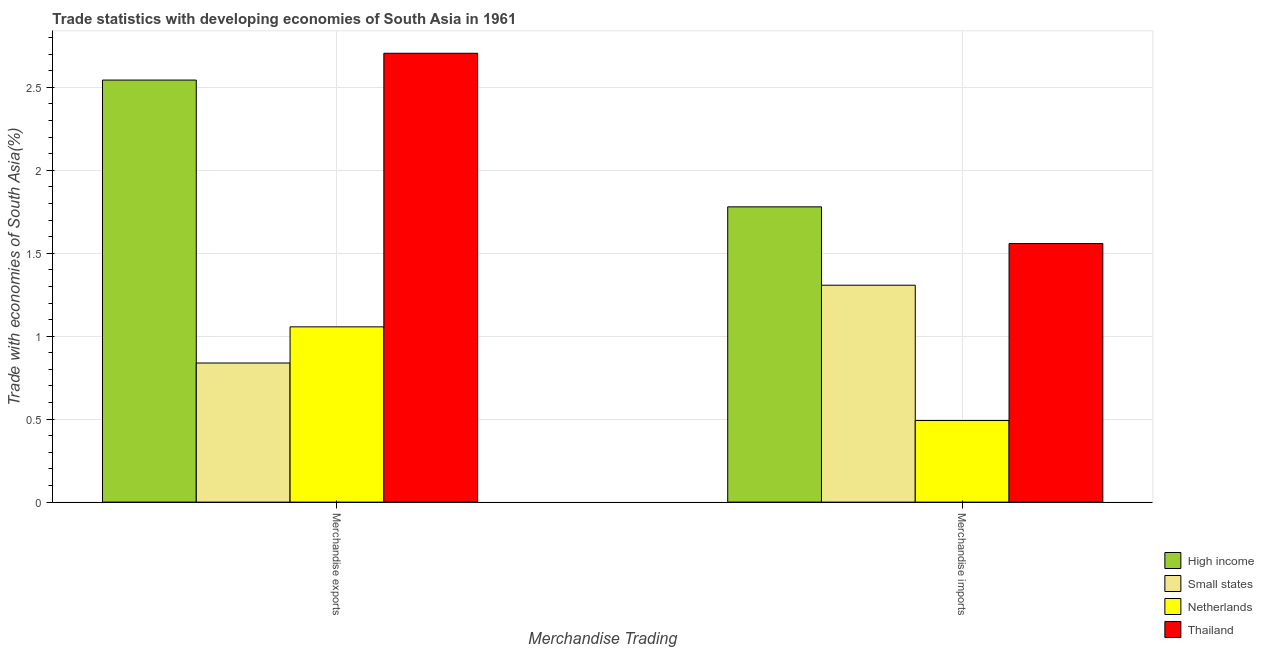How many different coloured bars are there?
Ensure brevity in your answer.  4. How many groups of bars are there?
Your response must be concise. 2. Are the number of bars per tick equal to the number of legend labels?
Give a very brief answer. Yes. How many bars are there on the 1st tick from the left?
Provide a short and direct response. 4. How many bars are there on the 2nd tick from the right?
Ensure brevity in your answer.  4. What is the merchandise imports in High income?
Provide a short and direct response. 1.78. Across all countries, what is the maximum merchandise exports?
Make the answer very short. 2.71. Across all countries, what is the minimum merchandise imports?
Your response must be concise. 0.49. In which country was the merchandise imports maximum?
Provide a short and direct response. High income. In which country was the merchandise imports minimum?
Make the answer very short. Netherlands. What is the total merchandise exports in the graph?
Ensure brevity in your answer.  7.14. What is the difference between the merchandise imports in Small states and that in High income?
Your response must be concise. -0.47. What is the difference between the merchandise exports in Netherlands and the merchandise imports in Small states?
Make the answer very short. -0.25. What is the average merchandise exports per country?
Ensure brevity in your answer.  1.79. What is the difference between the merchandise exports and merchandise imports in Thailand?
Provide a short and direct response. 1.15. What is the ratio of the merchandise exports in High income to that in Small states?
Provide a short and direct response. 3.03. Is the merchandise exports in Small states less than that in Thailand?
Offer a terse response. Yes. What does the 3rd bar from the left in Merchandise exports represents?
Make the answer very short. Netherlands. What does the 3rd bar from the right in Merchandise imports represents?
Provide a short and direct response. Small states. How many bars are there?
Keep it short and to the point. 8. Are all the bars in the graph horizontal?
Keep it short and to the point. No. How many countries are there in the graph?
Provide a short and direct response. 4. What is the difference between two consecutive major ticks on the Y-axis?
Your response must be concise. 0.5. Does the graph contain any zero values?
Your answer should be very brief. No. Where does the legend appear in the graph?
Ensure brevity in your answer.  Bottom right. How many legend labels are there?
Ensure brevity in your answer.  4. How are the legend labels stacked?
Provide a succinct answer. Vertical. What is the title of the graph?
Your response must be concise. Trade statistics with developing economies of South Asia in 1961. What is the label or title of the X-axis?
Offer a very short reply. Merchandise Trading. What is the label or title of the Y-axis?
Keep it short and to the point. Trade with economies of South Asia(%). What is the Trade with economies of South Asia(%) in High income in Merchandise exports?
Your answer should be compact. 2.54. What is the Trade with economies of South Asia(%) in Small states in Merchandise exports?
Ensure brevity in your answer.  0.84. What is the Trade with economies of South Asia(%) of Netherlands in Merchandise exports?
Offer a terse response. 1.06. What is the Trade with economies of South Asia(%) in Thailand in Merchandise exports?
Offer a very short reply. 2.71. What is the Trade with economies of South Asia(%) in High income in Merchandise imports?
Your answer should be compact. 1.78. What is the Trade with economies of South Asia(%) of Small states in Merchandise imports?
Your answer should be compact. 1.31. What is the Trade with economies of South Asia(%) in Netherlands in Merchandise imports?
Give a very brief answer. 0.49. What is the Trade with economies of South Asia(%) in Thailand in Merchandise imports?
Give a very brief answer. 1.56. Across all Merchandise Trading, what is the maximum Trade with economies of South Asia(%) of High income?
Keep it short and to the point. 2.54. Across all Merchandise Trading, what is the maximum Trade with economies of South Asia(%) of Small states?
Your answer should be very brief. 1.31. Across all Merchandise Trading, what is the maximum Trade with economies of South Asia(%) in Netherlands?
Provide a short and direct response. 1.06. Across all Merchandise Trading, what is the maximum Trade with economies of South Asia(%) of Thailand?
Provide a succinct answer. 2.71. Across all Merchandise Trading, what is the minimum Trade with economies of South Asia(%) of High income?
Provide a succinct answer. 1.78. Across all Merchandise Trading, what is the minimum Trade with economies of South Asia(%) in Small states?
Your answer should be very brief. 0.84. Across all Merchandise Trading, what is the minimum Trade with economies of South Asia(%) of Netherlands?
Offer a terse response. 0.49. Across all Merchandise Trading, what is the minimum Trade with economies of South Asia(%) in Thailand?
Make the answer very short. 1.56. What is the total Trade with economies of South Asia(%) in High income in the graph?
Provide a short and direct response. 4.32. What is the total Trade with economies of South Asia(%) in Small states in the graph?
Your answer should be compact. 2.15. What is the total Trade with economies of South Asia(%) of Netherlands in the graph?
Provide a succinct answer. 1.55. What is the total Trade with economies of South Asia(%) in Thailand in the graph?
Ensure brevity in your answer.  4.26. What is the difference between the Trade with economies of South Asia(%) in High income in Merchandise exports and that in Merchandise imports?
Your answer should be compact. 0.76. What is the difference between the Trade with economies of South Asia(%) of Small states in Merchandise exports and that in Merchandise imports?
Give a very brief answer. -0.47. What is the difference between the Trade with economies of South Asia(%) in Netherlands in Merchandise exports and that in Merchandise imports?
Provide a succinct answer. 0.56. What is the difference between the Trade with economies of South Asia(%) in Thailand in Merchandise exports and that in Merchandise imports?
Offer a terse response. 1.15. What is the difference between the Trade with economies of South Asia(%) in High income in Merchandise exports and the Trade with economies of South Asia(%) in Small states in Merchandise imports?
Provide a succinct answer. 1.24. What is the difference between the Trade with economies of South Asia(%) in High income in Merchandise exports and the Trade with economies of South Asia(%) in Netherlands in Merchandise imports?
Provide a short and direct response. 2.05. What is the difference between the Trade with economies of South Asia(%) of High income in Merchandise exports and the Trade with economies of South Asia(%) of Thailand in Merchandise imports?
Provide a short and direct response. 0.99. What is the difference between the Trade with economies of South Asia(%) in Small states in Merchandise exports and the Trade with economies of South Asia(%) in Netherlands in Merchandise imports?
Offer a terse response. 0.35. What is the difference between the Trade with economies of South Asia(%) of Small states in Merchandise exports and the Trade with economies of South Asia(%) of Thailand in Merchandise imports?
Your response must be concise. -0.72. What is the difference between the Trade with economies of South Asia(%) in Netherlands in Merchandise exports and the Trade with economies of South Asia(%) in Thailand in Merchandise imports?
Give a very brief answer. -0.5. What is the average Trade with economies of South Asia(%) of High income per Merchandise Trading?
Provide a short and direct response. 2.16. What is the average Trade with economies of South Asia(%) in Small states per Merchandise Trading?
Offer a very short reply. 1.07. What is the average Trade with economies of South Asia(%) of Netherlands per Merchandise Trading?
Offer a very short reply. 0.77. What is the average Trade with economies of South Asia(%) in Thailand per Merchandise Trading?
Offer a terse response. 2.13. What is the difference between the Trade with economies of South Asia(%) in High income and Trade with economies of South Asia(%) in Small states in Merchandise exports?
Keep it short and to the point. 1.71. What is the difference between the Trade with economies of South Asia(%) in High income and Trade with economies of South Asia(%) in Netherlands in Merchandise exports?
Your answer should be compact. 1.49. What is the difference between the Trade with economies of South Asia(%) of High income and Trade with economies of South Asia(%) of Thailand in Merchandise exports?
Your response must be concise. -0.16. What is the difference between the Trade with economies of South Asia(%) in Small states and Trade with economies of South Asia(%) in Netherlands in Merchandise exports?
Ensure brevity in your answer.  -0.22. What is the difference between the Trade with economies of South Asia(%) of Small states and Trade with economies of South Asia(%) of Thailand in Merchandise exports?
Offer a terse response. -1.87. What is the difference between the Trade with economies of South Asia(%) of Netherlands and Trade with economies of South Asia(%) of Thailand in Merchandise exports?
Your response must be concise. -1.65. What is the difference between the Trade with economies of South Asia(%) of High income and Trade with economies of South Asia(%) of Small states in Merchandise imports?
Offer a very short reply. 0.47. What is the difference between the Trade with economies of South Asia(%) of High income and Trade with economies of South Asia(%) of Netherlands in Merchandise imports?
Make the answer very short. 1.29. What is the difference between the Trade with economies of South Asia(%) in High income and Trade with economies of South Asia(%) in Thailand in Merchandise imports?
Offer a very short reply. 0.22. What is the difference between the Trade with economies of South Asia(%) of Small states and Trade with economies of South Asia(%) of Netherlands in Merchandise imports?
Make the answer very short. 0.82. What is the difference between the Trade with economies of South Asia(%) in Small states and Trade with economies of South Asia(%) in Thailand in Merchandise imports?
Provide a succinct answer. -0.25. What is the difference between the Trade with economies of South Asia(%) in Netherlands and Trade with economies of South Asia(%) in Thailand in Merchandise imports?
Ensure brevity in your answer.  -1.07. What is the ratio of the Trade with economies of South Asia(%) in High income in Merchandise exports to that in Merchandise imports?
Offer a very short reply. 1.43. What is the ratio of the Trade with economies of South Asia(%) in Small states in Merchandise exports to that in Merchandise imports?
Provide a succinct answer. 0.64. What is the ratio of the Trade with economies of South Asia(%) of Netherlands in Merchandise exports to that in Merchandise imports?
Your answer should be compact. 2.15. What is the ratio of the Trade with economies of South Asia(%) in Thailand in Merchandise exports to that in Merchandise imports?
Offer a very short reply. 1.74. What is the difference between the highest and the second highest Trade with economies of South Asia(%) of High income?
Offer a terse response. 0.76. What is the difference between the highest and the second highest Trade with economies of South Asia(%) of Small states?
Make the answer very short. 0.47. What is the difference between the highest and the second highest Trade with economies of South Asia(%) in Netherlands?
Make the answer very short. 0.56. What is the difference between the highest and the second highest Trade with economies of South Asia(%) of Thailand?
Offer a terse response. 1.15. What is the difference between the highest and the lowest Trade with economies of South Asia(%) in High income?
Provide a short and direct response. 0.76. What is the difference between the highest and the lowest Trade with economies of South Asia(%) of Small states?
Make the answer very short. 0.47. What is the difference between the highest and the lowest Trade with economies of South Asia(%) in Netherlands?
Your answer should be compact. 0.56. What is the difference between the highest and the lowest Trade with economies of South Asia(%) of Thailand?
Your answer should be compact. 1.15. 